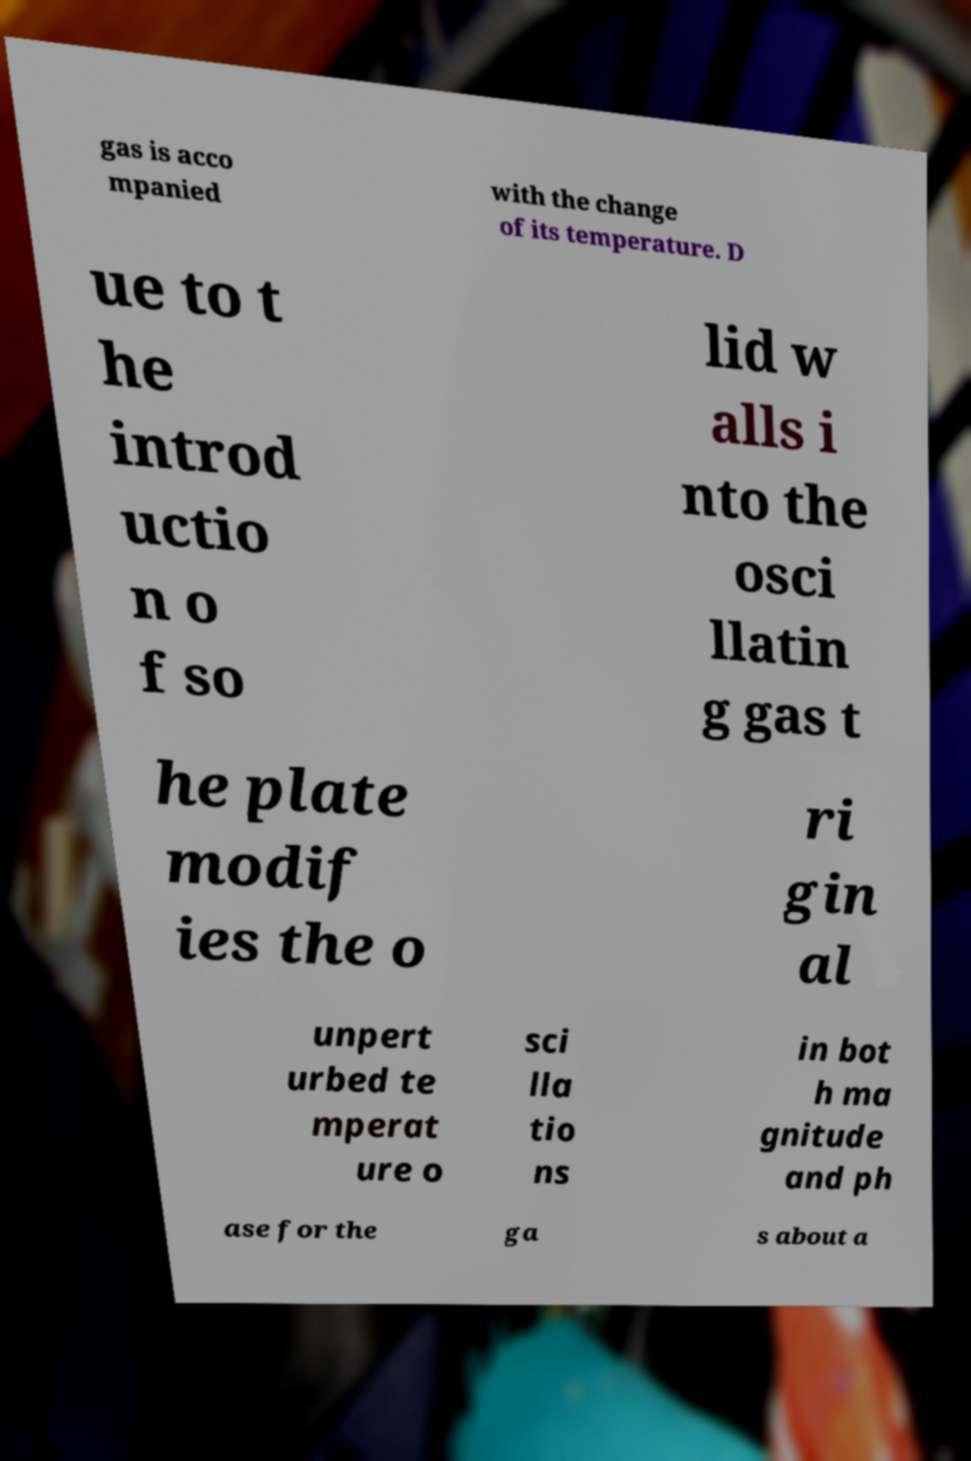There's text embedded in this image that I need extracted. Can you transcribe it verbatim? gas is acco mpanied with the change of its temperature. D ue to t he introd uctio n o f so lid w alls i nto the osci llatin g gas t he plate modif ies the o ri gin al unpert urbed te mperat ure o sci lla tio ns in bot h ma gnitude and ph ase for the ga s about a 